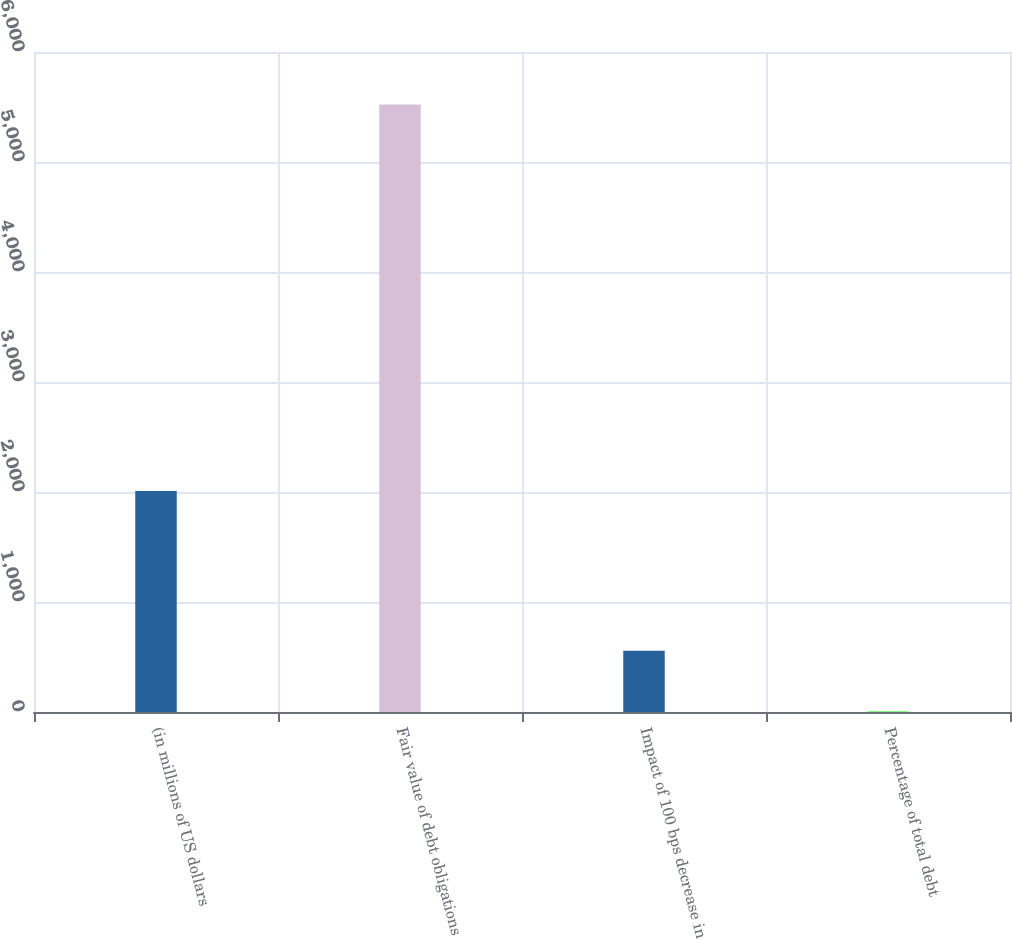Convert chart to OTSL. <chart><loc_0><loc_0><loc_500><loc_500><bar_chart><fcel>(in millions of US dollars<fcel>Fair value of debt obligations<fcel>Impact of 100 bps decrease in<fcel>Percentage of total debt<nl><fcel>2010<fcel>5522<fcel>556.79<fcel>5.1<nl></chart> 